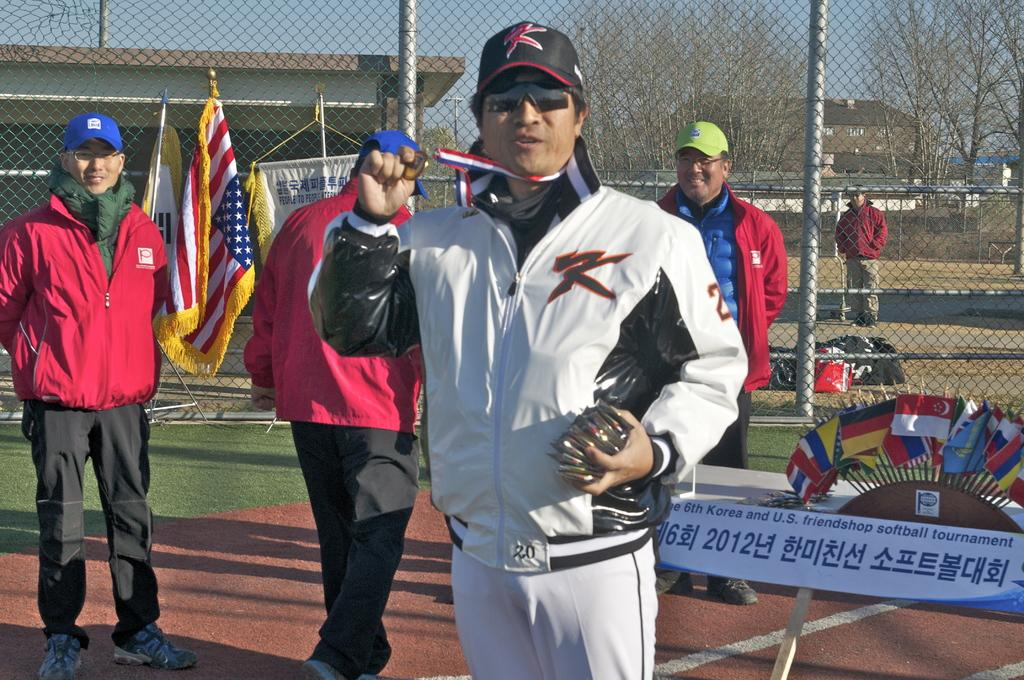<image>
Relay a brief, clear account of the picture shown. A man with the number 20 on the bottom of his white jacket stands near several country flags 